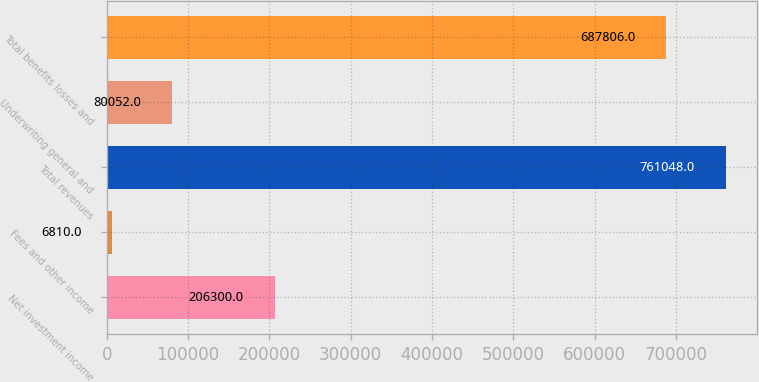Convert chart to OTSL. <chart><loc_0><loc_0><loc_500><loc_500><bar_chart><fcel>Net investment income<fcel>Fees and other income<fcel>Total revenues<fcel>Underwriting general and<fcel>Total benefits losses and<nl><fcel>206300<fcel>6810<fcel>761048<fcel>80052<fcel>687806<nl></chart> 